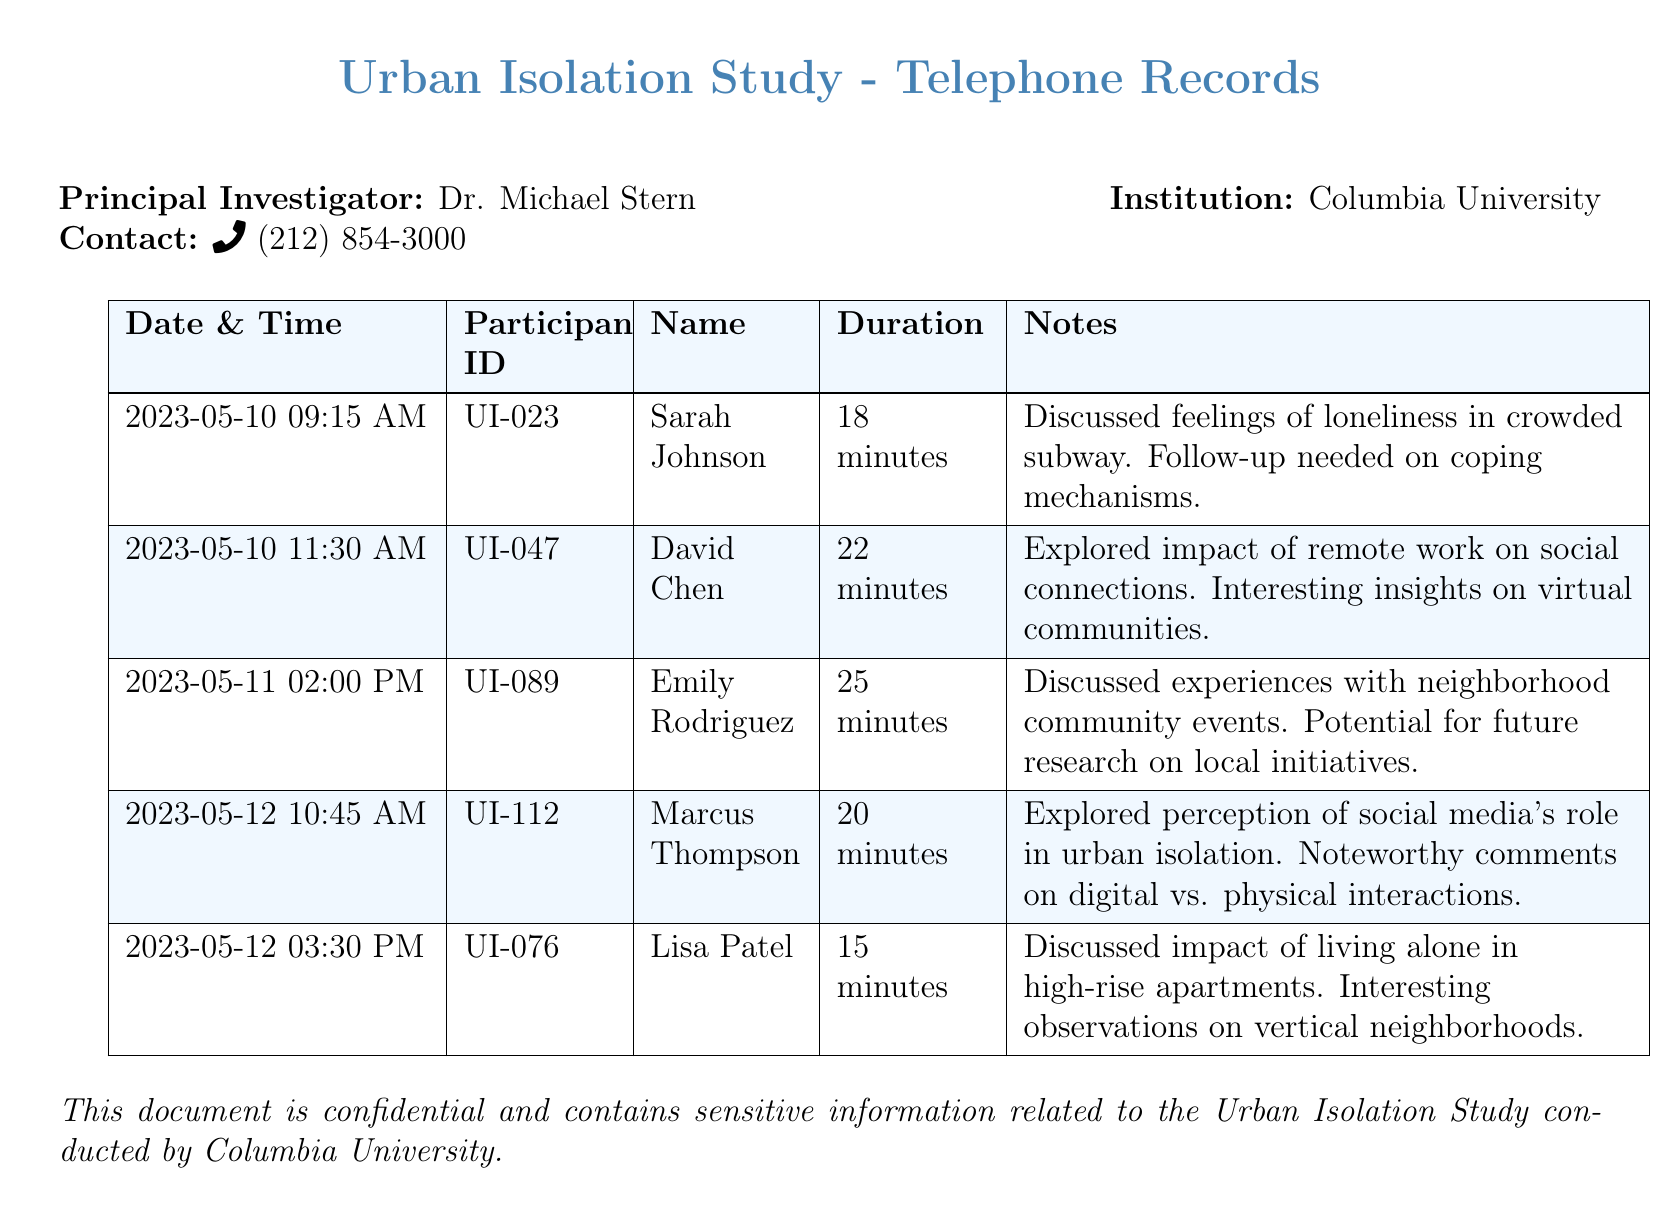What is the date of the first recorded call? The first recorded call was made on May 10, 2023, at 09:15 AM.
Answer: May 10, 2023 How long was the call with Emily Rodriguez? The duration of the call with Emily Rodriguez was recorded to be 25 minutes.
Answer: 25 minutes What is the participant ID of Lisa Patel? Lisa Patel's participant ID is UI-076.
Answer: UI-076 What topic did Marcus Thompson discuss? Marcus Thompson explored the perception of social media's role in urban isolation.
Answer: Social media's role in urban isolation How many calls were recorded on May 12, 2023? There were two calls recorded on May 12, 2023.
Answer: Two calls What is the significance of the notes for David Chen's call? The notes indicate interesting insights on virtual communities related to remote work's impact on social connections.
Answer: Insights on virtual communities Which participant discussed feelings of loneliness in the subway? Sarah Johnson discussed feelings of loneliness in the crowded subway.
Answer: Sarah Johnson What was the duration of Lisa Patel's call? The duration of Lisa Patel's call was recorded at 15 minutes.
Answer: 15 minutes 